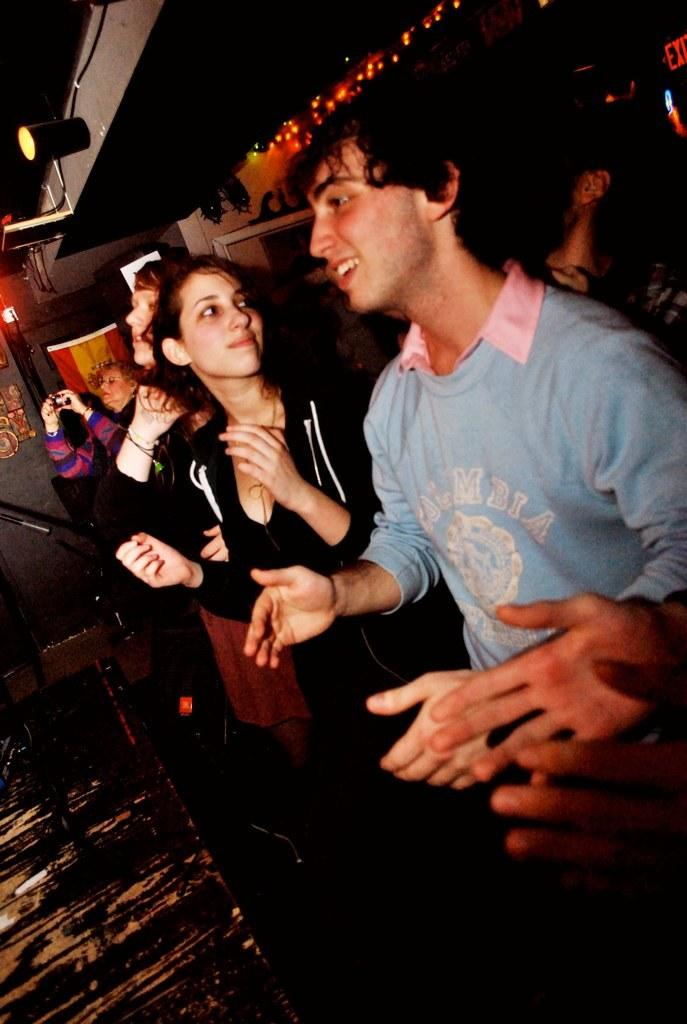How many individuals are present in the image? There are many people in the image. Can you describe the clothing of one of the individuals? There is a boy wearing a blue T-shirt in the image. Can you describe the clothing of another individual? There is a girl wearing a black jacket in the image. What type of establishment might the setting be? The setting appears to be a pub. What is visible at the top of the image? There is a lamp visible at the top of the image. What songs are being sung by the people in the image? There is no information about songs being sung in the image. Can you see any cobwebs in the image? There is no mention of cobwebs in the image. 